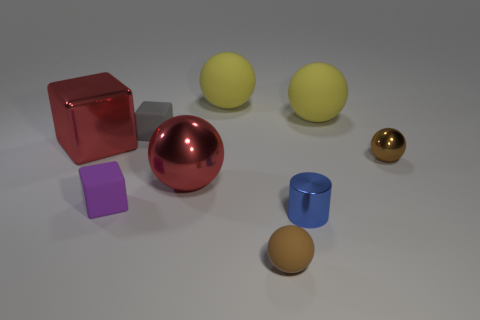Is there a pattern to the arrangement of these objects? There doesn't appear to be a strict pattern, but the objects are somewhat spaced out evenly, which may suggest an intentional arrangement for either aesthetic appeal or for an exercise in spatial awareness. 